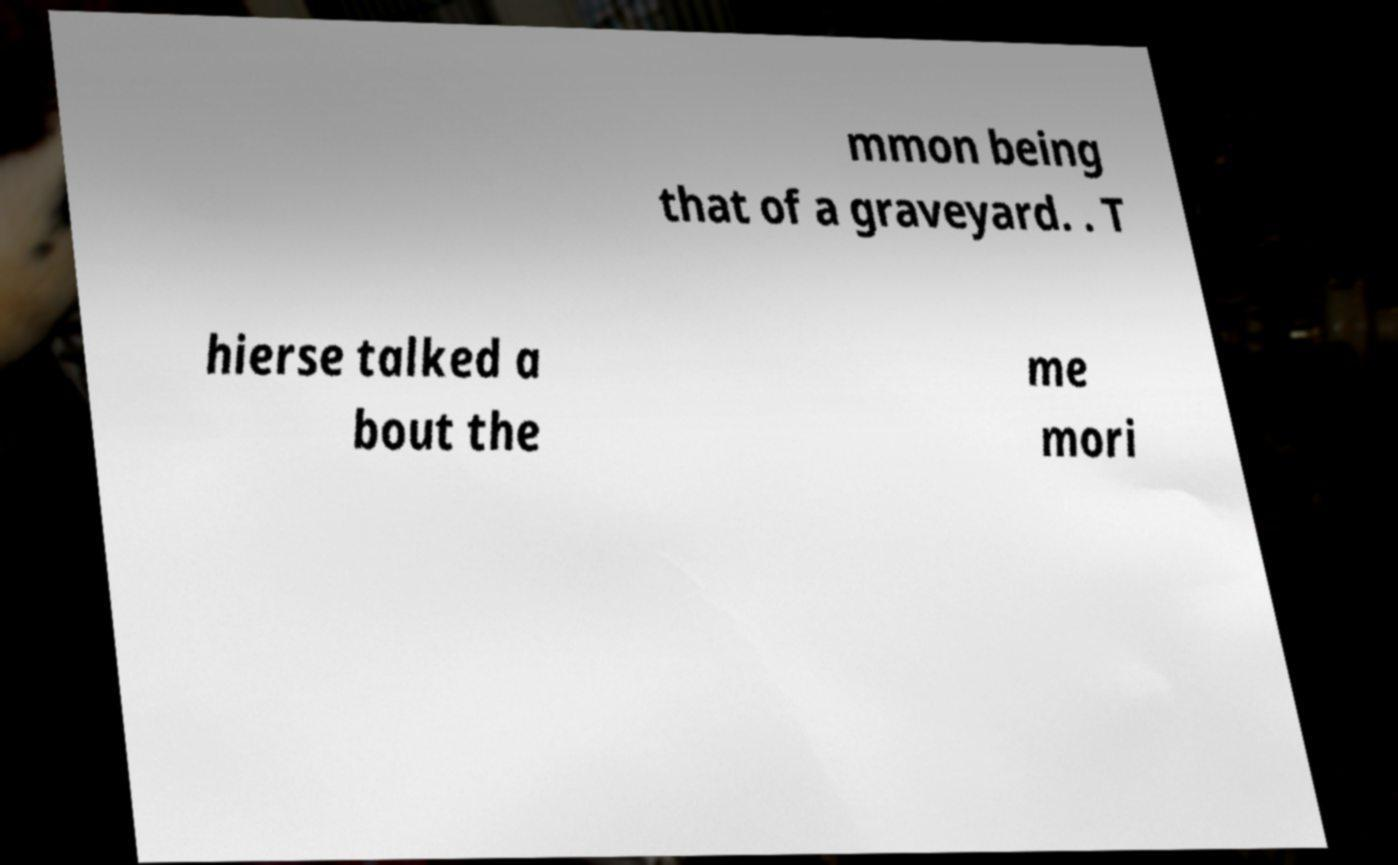Can you read and provide the text displayed in the image?This photo seems to have some interesting text. Can you extract and type it out for me? mmon being that of a graveyard. . T hierse talked a bout the me mori 